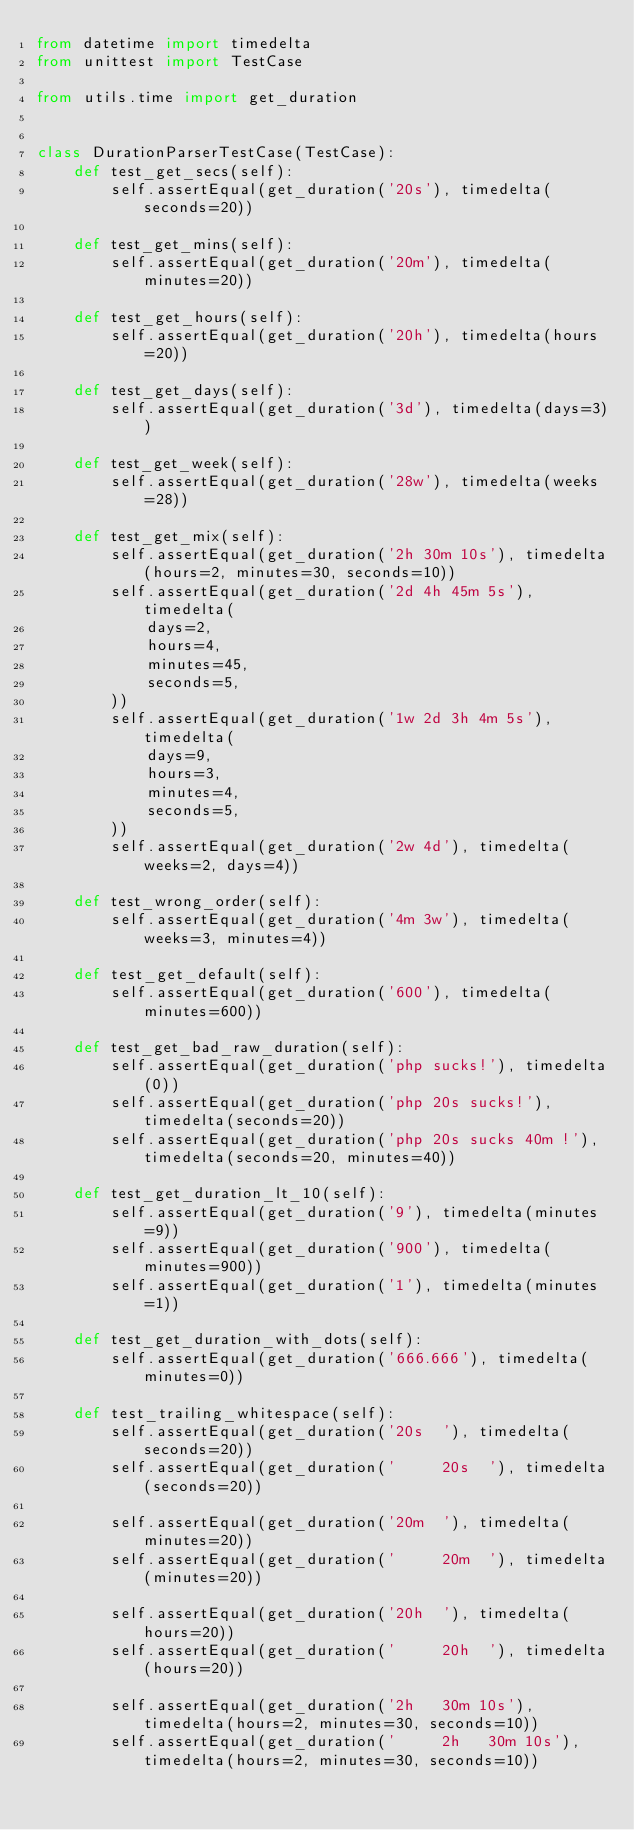<code> <loc_0><loc_0><loc_500><loc_500><_Python_>from datetime import timedelta
from unittest import TestCase

from utils.time import get_duration


class DurationParserTestCase(TestCase):
    def test_get_secs(self):
        self.assertEqual(get_duration('20s'), timedelta(seconds=20))

    def test_get_mins(self):
        self.assertEqual(get_duration('20m'), timedelta(minutes=20))

    def test_get_hours(self):
        self.assertEqual(get_duration('20h'), timedelta(hours=20))

    def test_get_days(self):
        self.assertEqual(get_duration('3d'), timedelta(days=3))

    def test_get_week(self):
        self.assertEqual(get_duration('28w'), timedelta(weeks=28))

    def test_get_mix(self):
        self.assertEqual(get_duration('2h 30m 10s'), timedelta(hours=2, minutes=30, seconds=10))
        self.assertEqual(get_duration('2d 4h 45m 5s'), timedelta(
            days=2,
            hours=4,
            minutes=45,
            seconds=5,
        ))
        self.assertEqual(get_duration('1w 2d 3h 4m 5s'), timedelta(
            days=9,
            hours=3,
            minutes=4,
            seconds=5,
        ))
        self.assertEqual(get_duration('2w 4d'), timedelta(weeks=2, days=4))

    def test_wrong_order(self):
        self.assertEqual(get_duration('4m 3w'), timedelta(weeks=3, minutes=4))

    def test_get_default(self):
        self.assertEqual(get_duration('600'), timedelta(minutes=600))

    def test_get_bad_raw_duration(self):
        self.assertEqual(get_duration('php sucks!'), timedelta(0))
        self.assertEqual(get_duration('php 20s sucks!'), timedelta(seconds=20))
        self.assertEqual(get_duration('php 20s sucks 40m !'), timedelta(seconds=20, minutes=40))

    def test_get_duration_lt_10(self):
        self.assertEqual(get_duration('9'), timedelta(minutes=9))
        self.assertEqual(get_duration('900'), timedelta(minutes=900))
        self.assertEqual(get_duration('1'), timedelta(minutes=1))

    def test_get_duration_with_dots(self):
        self.assertEqual(get_duration('666.666'), timedelta(minutes=0))

    def test_trailing_whitespace(self):
        self.assertEqual(get_duration('20s  '), timedelta(seconds=20))
        self.assertEqual(get_duration('     20s  '), timedelta(seconds=20))

        self.assertEqual(get_duration('20m  '), timedelta(minutes=20))
        self.assertEqual(get_duration('     20m  '), timedelta(minutes=20))

        self.assertEqual(get_duration('20h  '), timedelta(hours=20))
        self.assertEqual(get_duration('     20h  '), timedelta(hours=20))

        self.assertEqual(get_duration('2h   30m 10s'), timedelta(hours=2, minutes=30, seconds=10))
        self.assertEqual(get_duration('     2h   30m 10s'), timedelta(hours=2, minutes=30, seconds=10))
</code> 